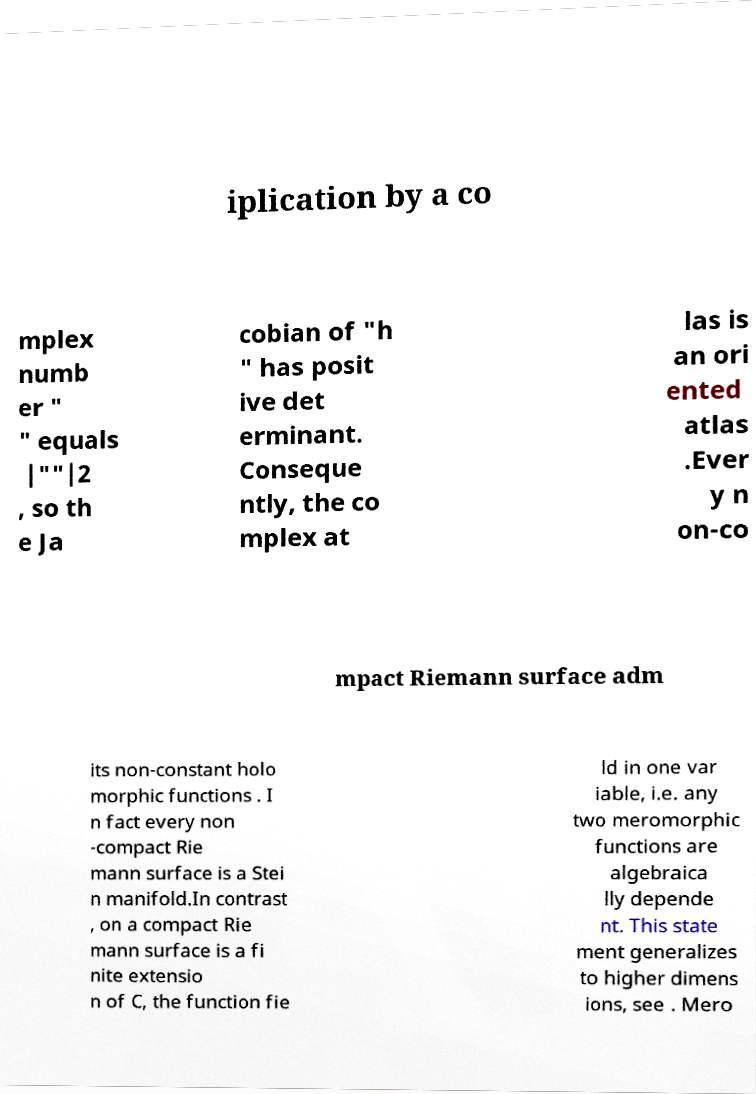For documentation purposes, I need the text within this image transcribed. Could you provide that? iplication by a co mplex numb er " " equals |""|2 , so th e Ja cobian of "h " has posit ive det erminant. Conseque ntly, the co mplex at las is an ori ented atlas .Ever y n on-co mpact Riemann surface adm its non-constant holo morphic functions . I n fact every non -compact Rie mann surface is a Stei n manifold.In contrast , on a compact Rie mann surface is a fi nite extensio n of C, the function fie ld in one var iable, i.e. any two meromorphic functions are algebraica lly depende nt. This state ment generalizes to higher dimens ions, see . Mero 